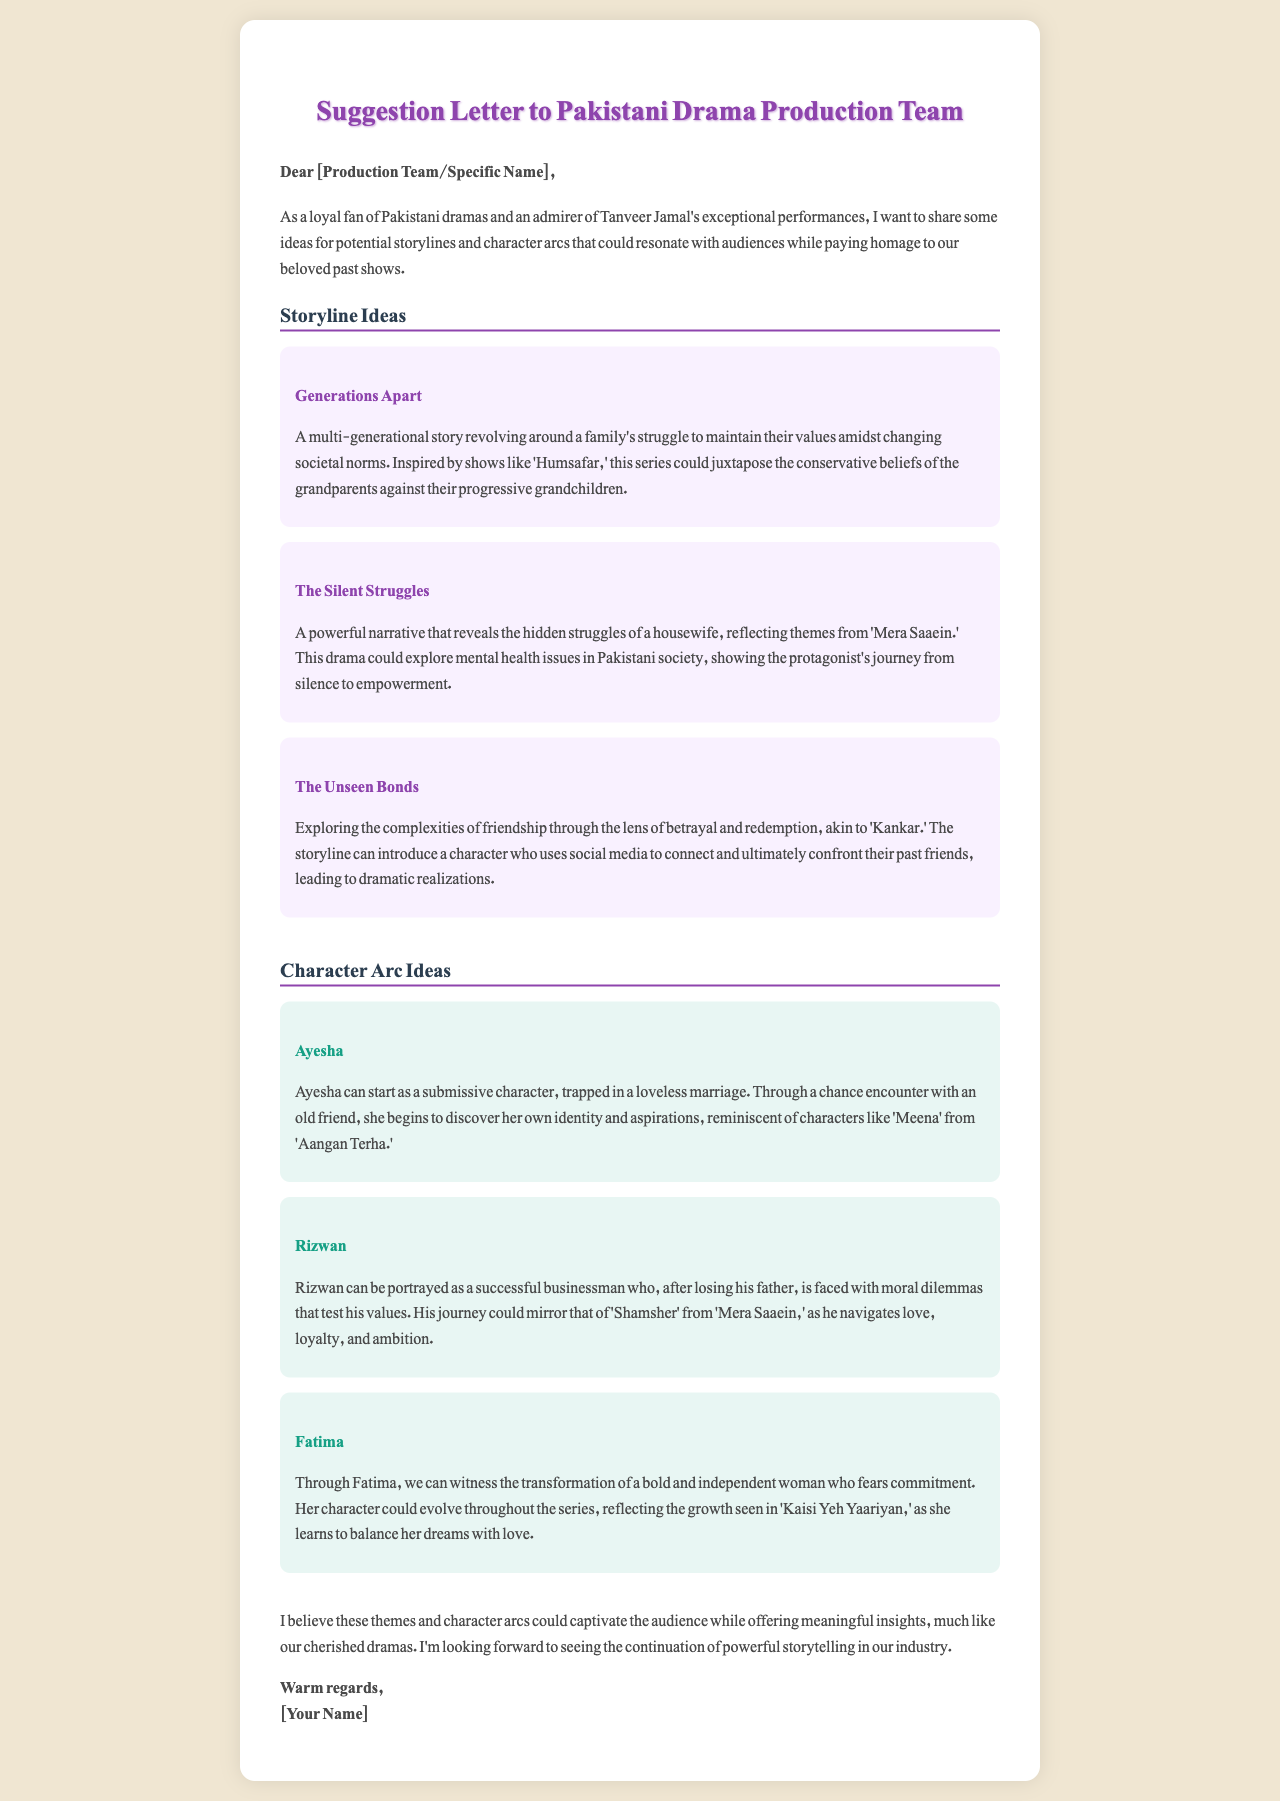What is the title of the letter? The title of the letter is displayed prominently at the top of the document.
Answer: Suggestion Letter to Pakistani Drama Production Team Who is the letter addressed to? The letter begins with a greeting that mentions either a specific name or a general title.
Answer: [Production Team/Specific Name] What is the first storyline idea mentioned? The first storyline idea is presented in a dedicated section of the letter.
Answer: Generations Apart Which character arc involves a character named Ayesha? Ayesha's character arc is detailed in the section regarding character arcs of the letter.
Answer: Ayesha What themes does the storyline "The Silent Struggles" explore? The themes explored in this storyline are articulated in the context of the narrative in the document.
Answer: Mental health issues Which show is mentioned as a source of inspiration for the character Rizwan? Rizwan's character arc references a specific show that influenced its development.
Answer: Mera Saaein What sentiment does the author express towards the end of the letter? The closing paragraph conveys the author's hopes regarding the continuation of a certain aspect in the industry.
Answer: Powerful storytelling What style of drama does the author express admiration for? The author shares their fondness for a specific genre in the introduction to the letter.
Answer: Pakistani dramas 